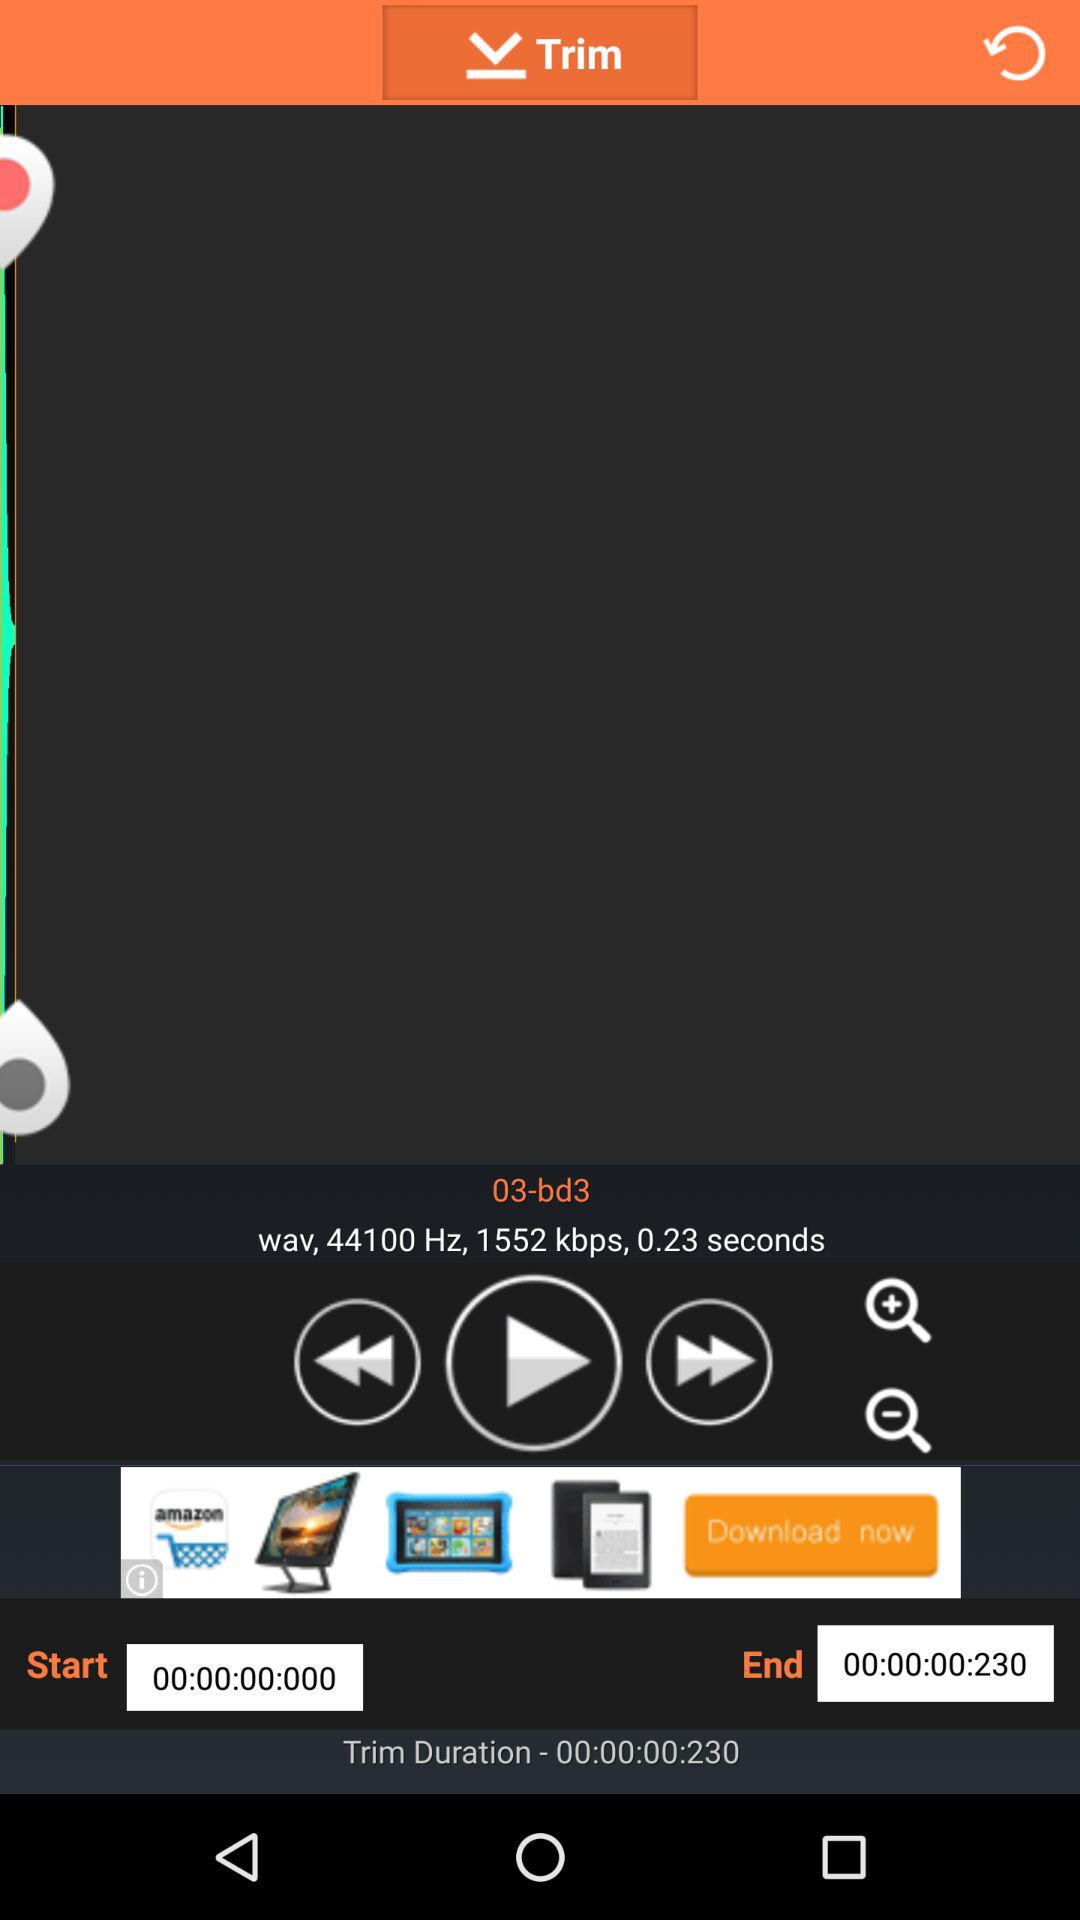What is the frequency? The frequency is 44100 Hz. 